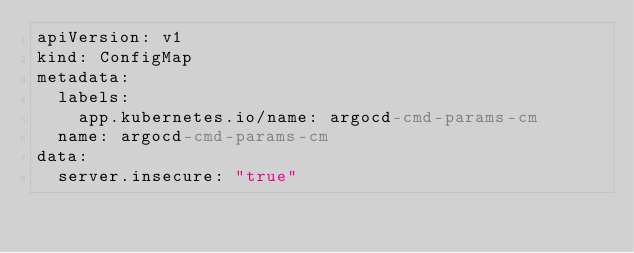Convert code to text. <code><loc_0><loc_0><loc_500><loc_500><_YAML_>apiVersion: v1
kind: ConfigMap
metadata:
  labels:
    app.kubernetes.io/name: argocd-cmd-params-cm
  name: argocd-cmd-params-cm
data:
  server.insecure: "true"</code> 